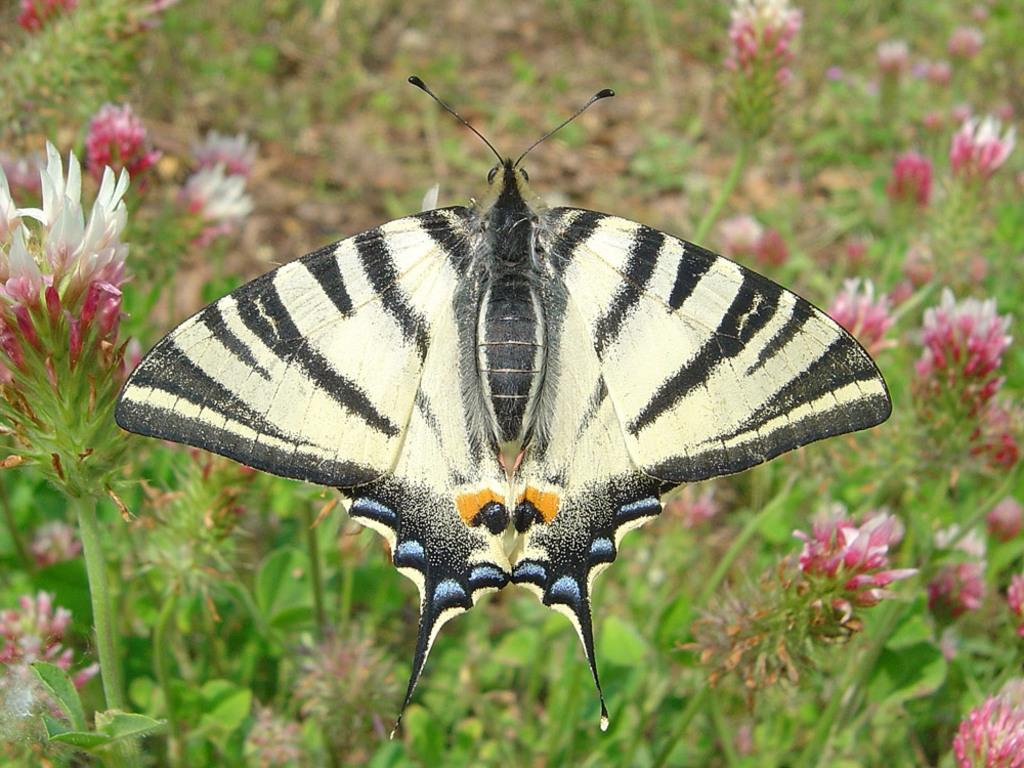What type of creature is present in the image? There is a butterfly in the image. What colors can be seen on the butterfly? The butterfly has yellow, black, and orange colors. What can be seen in the background of the image? There are plants and flowers in the background of the image. What colors are the flowers? The flowers have pink and white colors. What type of notebook is the owl using to write in the image? There is no owl or notebook present in the image; it features a butterfly and flowers. What flavor of jam is the butterfly sitting on in the image? There is no jam present in the image; the butterfly is not sitting on any food item. 